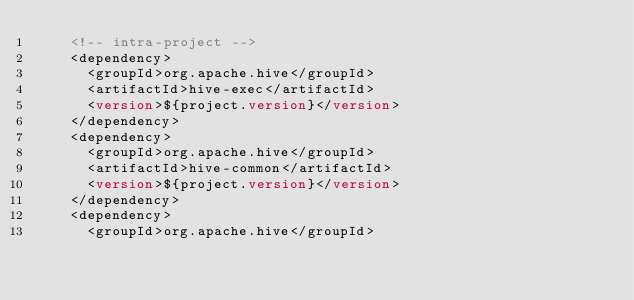<code> <loc_0><loc_0><loc_500><loc_500><_XML_>    <!-- intra-project -->
    <dependency>
      <groupId>org.apache.hive</groupId>
      <artifactId>hive-exec</artifactId>
      <version>${project.version}</version>
    </dependency>
    <dependency>
      <groupId>org.apache.hive</groupId>
      <artifactId>hive-common</artifactId>
      <version>${project.version}</version>
    </dependency>
    <dependency>
      <groupId>org.apache.hive</groupId></code> 